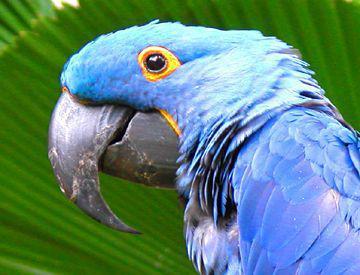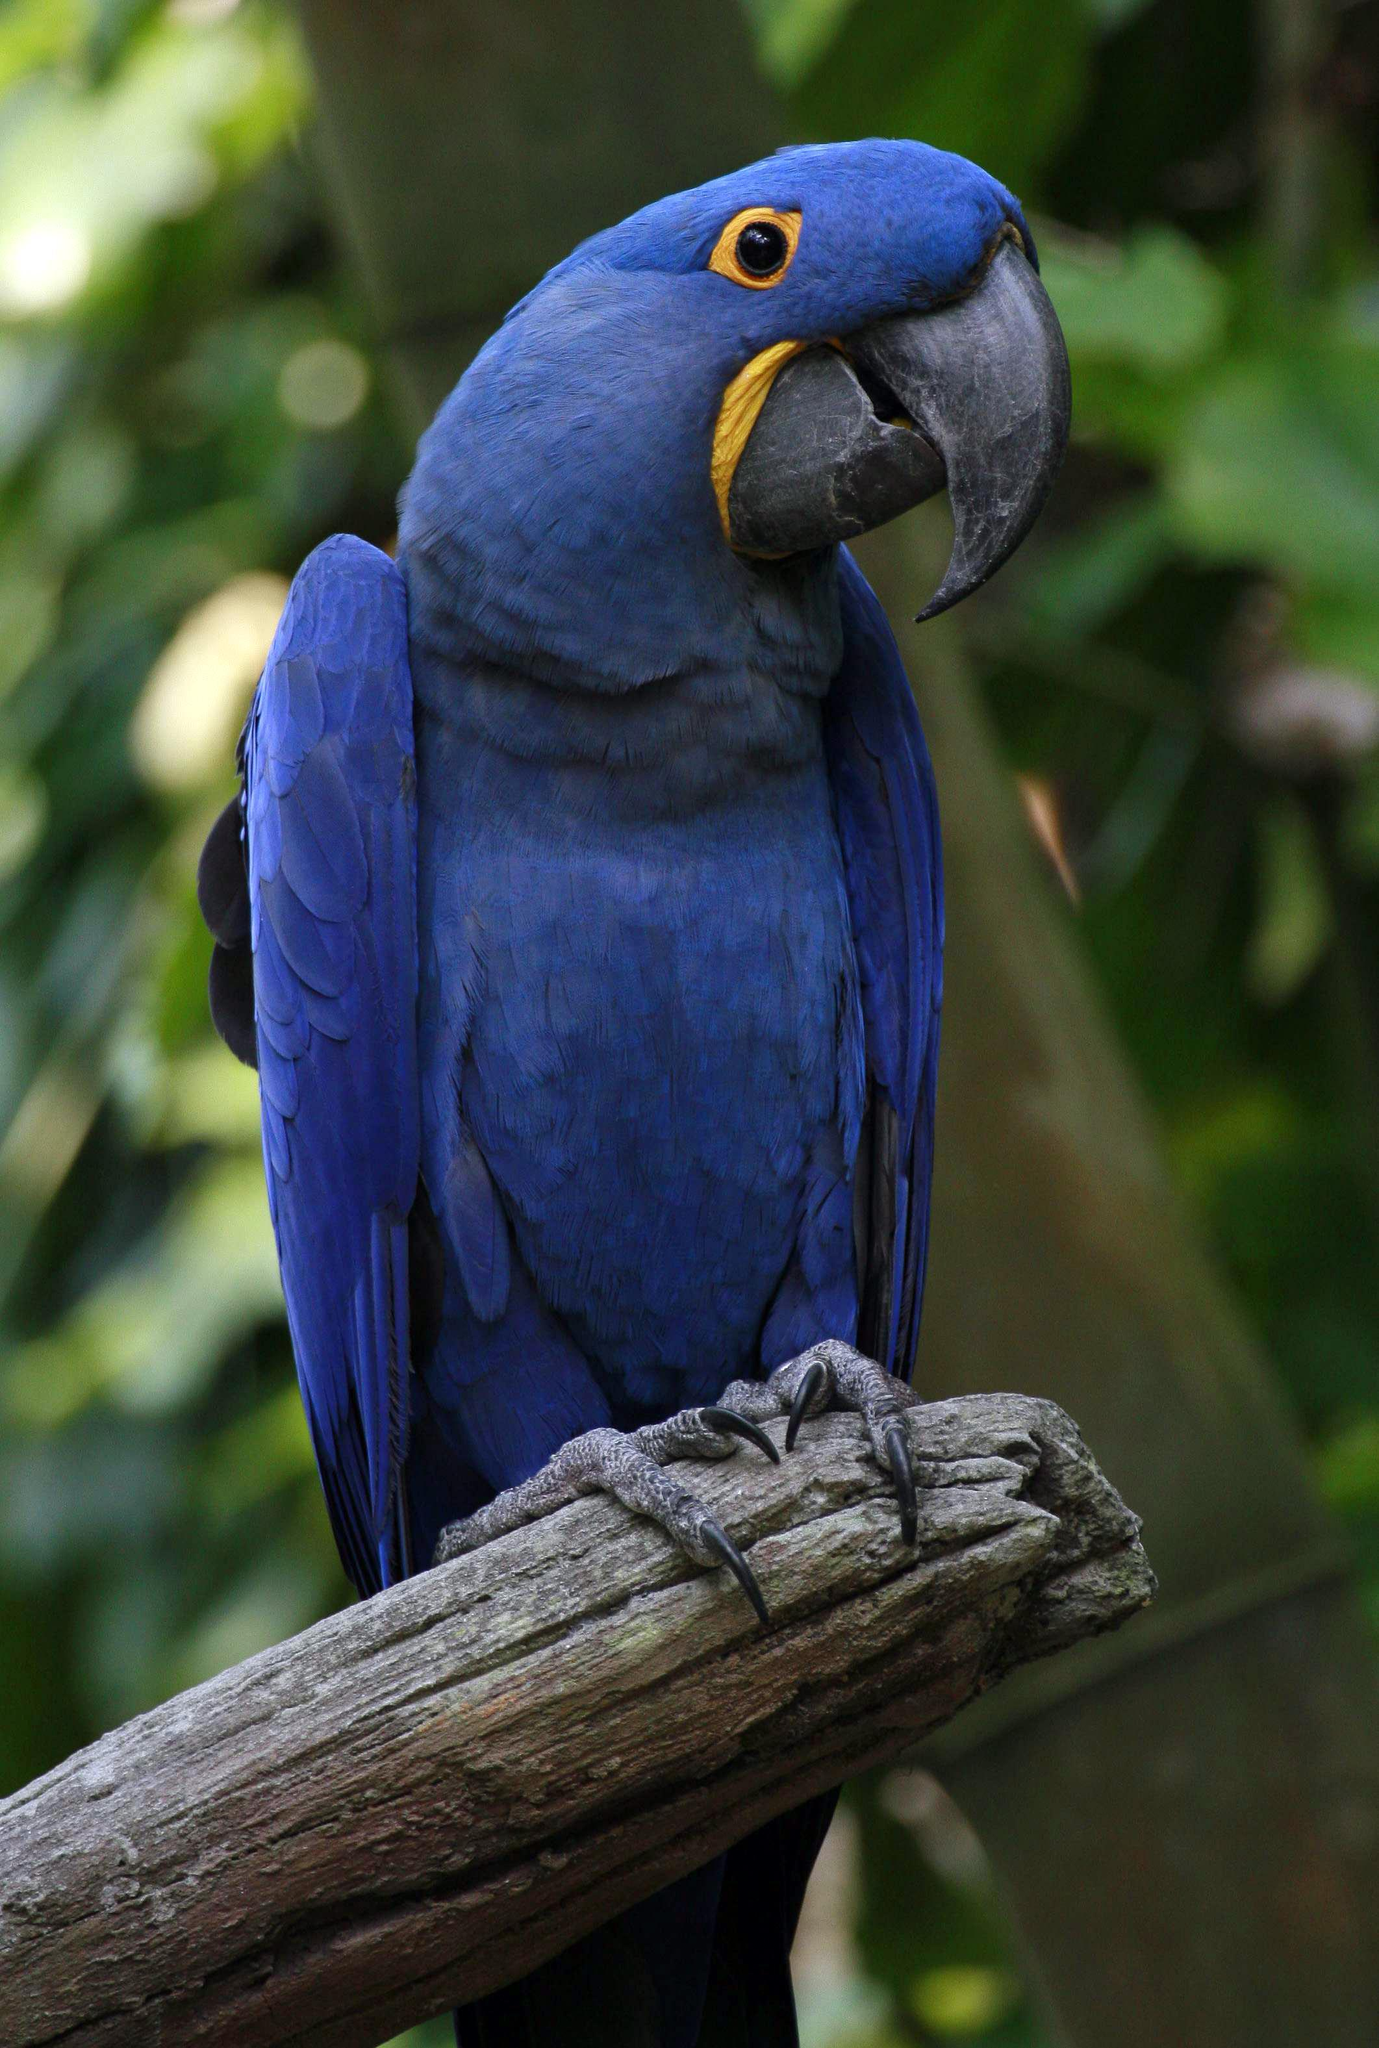The first image is the image on the left, the second image is the image on the right. Examine the images to the left and right. Is the description "There are two birds" accurate? Answer yes or no. Yes. 